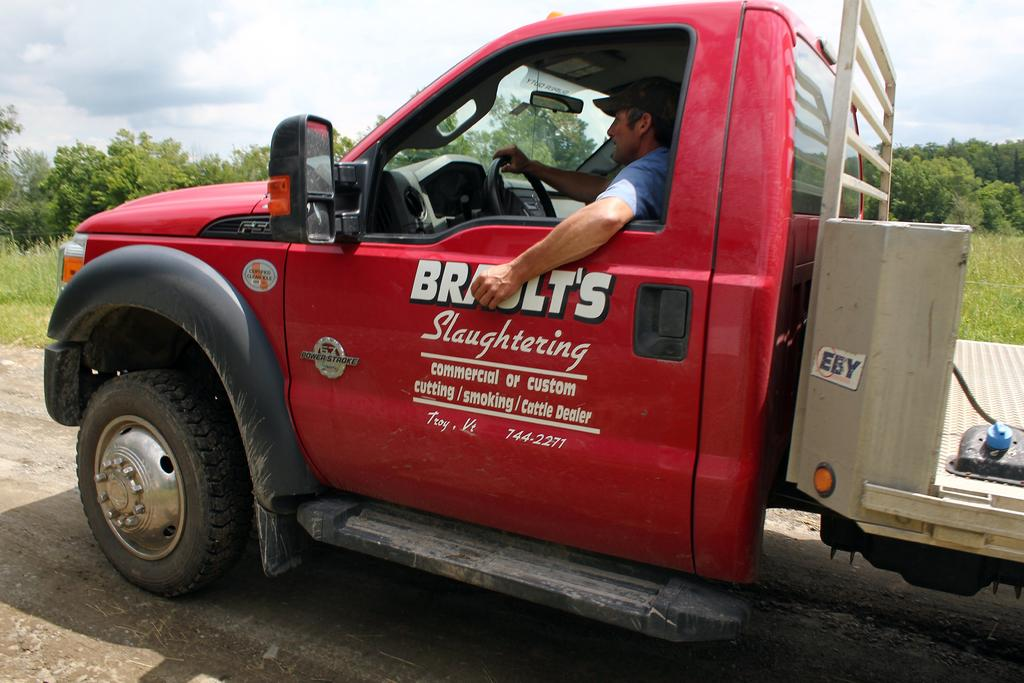What is the person in the image doing? There is a person sitting in a vehicle in the image. What can be seen in the background of the image? There is grass, trees, and clouds in the sky visible in the background. What type of ornament is hanging from the trees in the image? There is no ornament hanging from the trees in the image; only grass, trees, and clouds in the sky are visible in the background. 